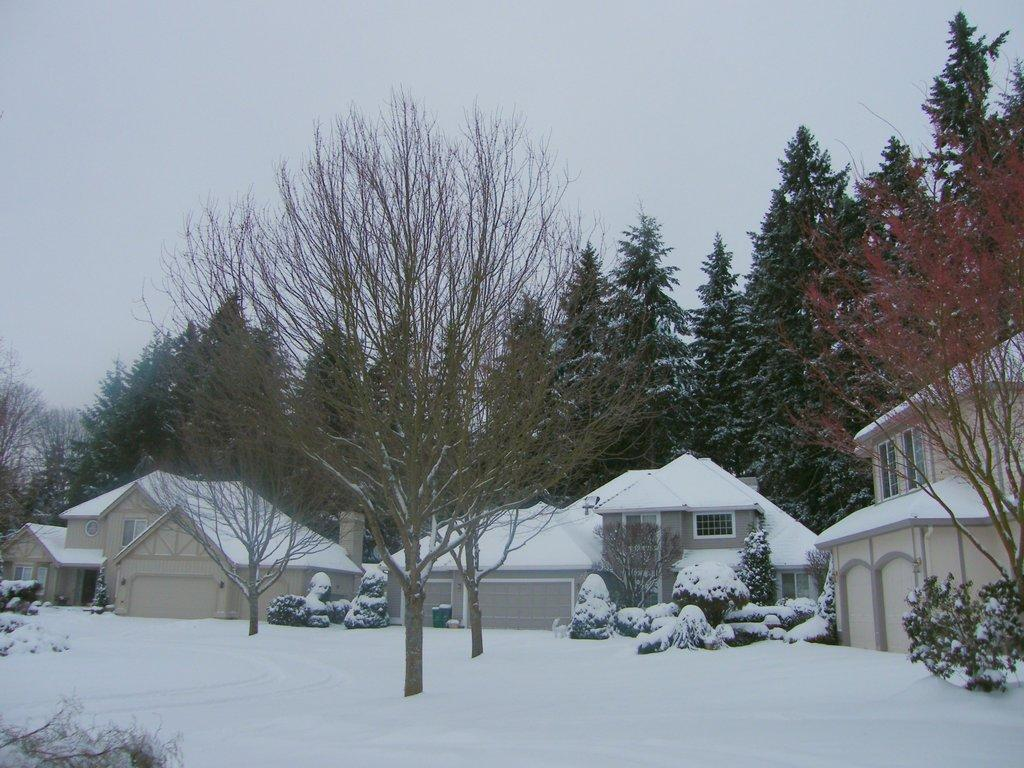What type of weather is depicted in the image? There is snow in the image, indicating a snowy or wintry weather. What type of structures can be seen in the image? There are buildings in the image. What type of vegetation is present in the image? There are bushes and trees in the image. What is visible in the sky in the image? The sky is visible in the image. Can you see a cat flying through the air in the image? There is no cat present in the image, let alone one that is flying. Is there a brain visible in the image? There is no brain present in the image. 